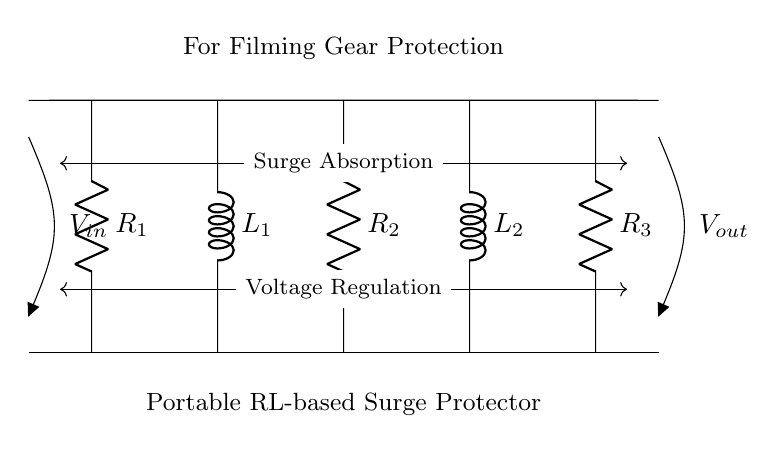What is the input voltage in this circuit? The input voltage is represented by \( V_{in} \) at the left side of the circuit diagram, which shows where the external power source connects.
Answer: Vin How many resistors are present in this circuit? The circuit diagram shows three resistors labeled \( R_1, R_2, \) and \( R_3 \), indicating their quantity.
Answer: 3 What is the function of the inductors in this RL-based surge protector? The inductors, labeled \( L_1 \) and \( L_2 \), serve to manage current flow and help absorb surges, reducing the risk of damage to connected equipment.
Answer: Surge absorption What would happen to the circuit if \( R_1 \) is removed? Removing \( R_1 \) would interrupt the current flow entering the circuit and disrupt its functionality, as it connects the input voltage to the circuit.
Answer: Circuit interruption What is the relationship between voltage regulation and the components in the circuit? The voltage regulation feature, indicated in the diagram, depends on the resistors and inductors working together to maintain a stable output voltage despite surges.
Answer: Stable output What type of protection does this circuit provide for filming gear? This circuit provides surge protection by absorbing spikes in voltage, which safeguards sensitive filming equipment from damage caused by overloads.
Answer: Surge protection What is the output voltage in this circuit? The output voltage, represented by \( V_{out} \) at the right side of the circuit diagram, shows where the controlled output voltage can be measured.
Answer: Vout 